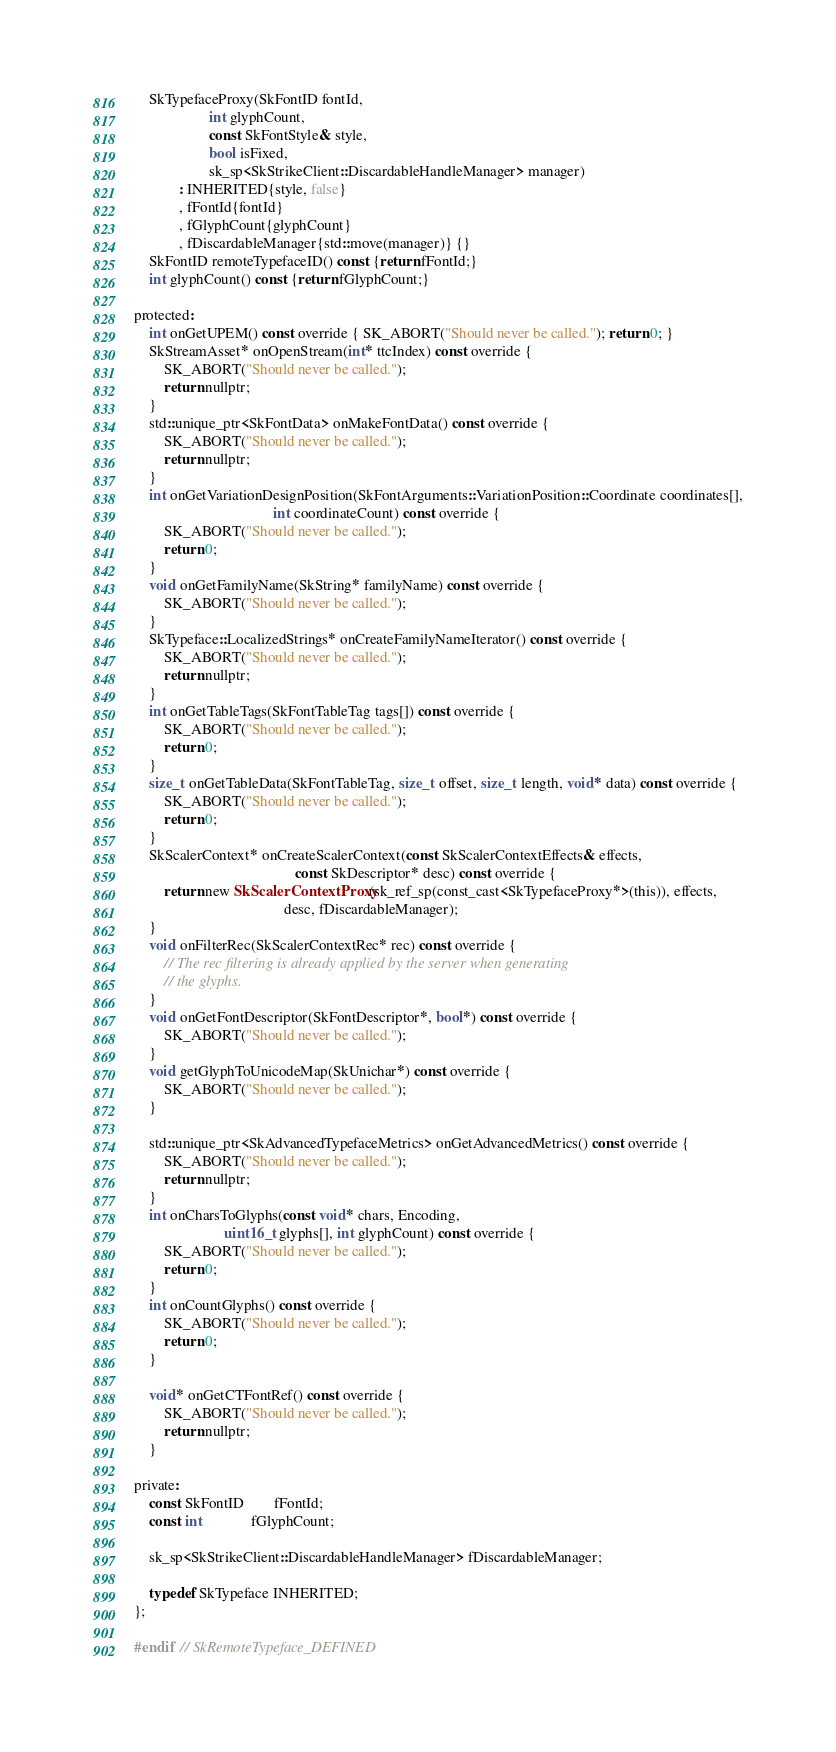<code> <loc_0><loc_0><loc_500><loc_500><_C_>    SkTypefaceProxy(SkFontID fontId,
                    int glyphCount,
                    const SkFontStyle& style,
                    bool isFixed,
                    sk_sp<SkStrikeClient::DiscardableHandleManager> manager)
            : INHERITED{style, false}
            , fFontId{fontId}
            , fGlyphCount{glyphCount}
            , fDiscardableManager{std::move(manager)} {}
    SkFontID remoteTypefaceID() const {return fFontId;}
    int glyphCount() const {return fGlyphCount;}

protected:
    int onGetUPEM() const override { SK_ABORT("Should never be called."); return 0; }
    SkStreamAsset* onOpenStream(int* ttcIndex) const override {
        SK_ABORT("Should never be called.");
        return nullptr;
    }
    std::unique_ptr<SkFontData> onMakeFontData() const override {
        SK_ABORT("Should never be called.");
        return nullptr;
    }
    int onGetVariationDesignPosition(SkFontArguments::VariationPosition::Coordinate coordinates[],
                                     int coordinateCount) const override {
        SK_ABORT("Should never be called.");
        return 0;
    }
    void onGetFamilyName(SkString* familyName) const override {
        SK_ABORT("Should never be called.");
    }
    SkTypeface::LocalizedStrings* onCreateFamilyNameIterator() const override {
        SK_ABORT("Should never be called.");
        return nullptr;
    }
    int onGetTableTags(SkFontTableTag tags[]) const override {
        SK_ABORT("Should never be called.");
        return 0;
    }
    size_t onGetTableData(SkFontTableTag, size_t offset, size_t length, void* data) const override {
        SK_ABORT("Should never be called.");
        return 0;
    }
    SkScalerContext* onCreateScalerContext(const SkScalerContextEffects& effects,
                                           const SkDescriptor* desc) const override {
        return new SkScalerContextProxy(sk_ref_sp(const_cast<SkTypefaceProxy*>(this)), effects,
                                        desc, fDiscardableManager);
    }
    void onFilterRec(SkScalerContextRec* rec) const override {
        // The rec filtering is already applied by the server when generating
        // the glyphs.
    }
    void onGetFontDescriptor(SkFontDescriptor*, bool*) const override {
        SK_ABORT("Should never be called.");
    }
    void getGlyphToUnicodeMap(SkUnichar*) const override {
        SK_ABORT("Should never be called.");
    }

    std::unique_ptr<SkAdvancedTypefaceMetrics> onGetAdvancedMetrics() const override {
        SK_ABORT("Should never be called.");
        return nullptr;
    }
    int onCharsToGlyphs(const void* chars, Encoding,
                        uint16_t glyphs[], int glyphCount) const override {
        SK_ABORT("Should never be called.");
        return 0;
    }
    int onCountGlyphs() const override {
        SK_ABORT("Should never be called.");
        return 0;
    }

    void* onGetCTFontRef() const override {
        SK_ABORT("Should never be called.");
        return nullptr;
    }

private:
    const SkFontID        fFontId;
    const int             fGlyphCount;

    sk_sp<SkStrikeClient::DiscardableHandleManager> fDiscardableManager;

    typedef SkTypeface INHERITED;
};

#endif  // SkRemoteTypeface_DEFINED
</code> 